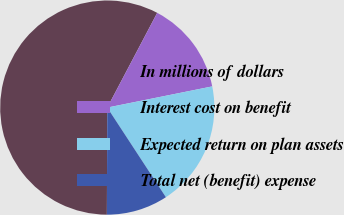Convert chart to OTSL. <chart><loc_0><loc_0><loc_500><loc_500><pie_chart><fcel>In millions of dollars<fcel>Interest cost on benefit<fcel>Expected return on plan assets<fcel>Total net (benefit) expense<nl><fcel>57.66%<fcel>14.11%<fcel>18.95%<fcel>9.28%<nl></chart> 